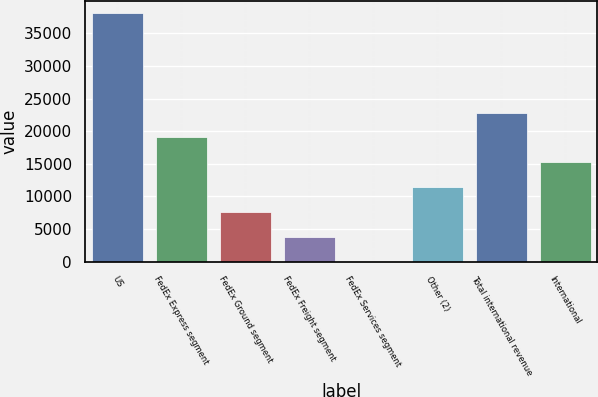<chart> <loc_0><loc_0><loc_500><loc_500><bar_chart><fcel>US<fcel>FedEx Express segment<fcel>FedEx Ground segment<fcel>FedEx Freight segment<fcel>FedEx Services segment<fcel>Other (2)<fcel>Total international revenue<fcel>International<nl><fcel>38070<fcel>19040<fcel>7622<fcel>3816<fcel>10<fcel>11428<fcel>22846<fcel>15234<nl></chart> 